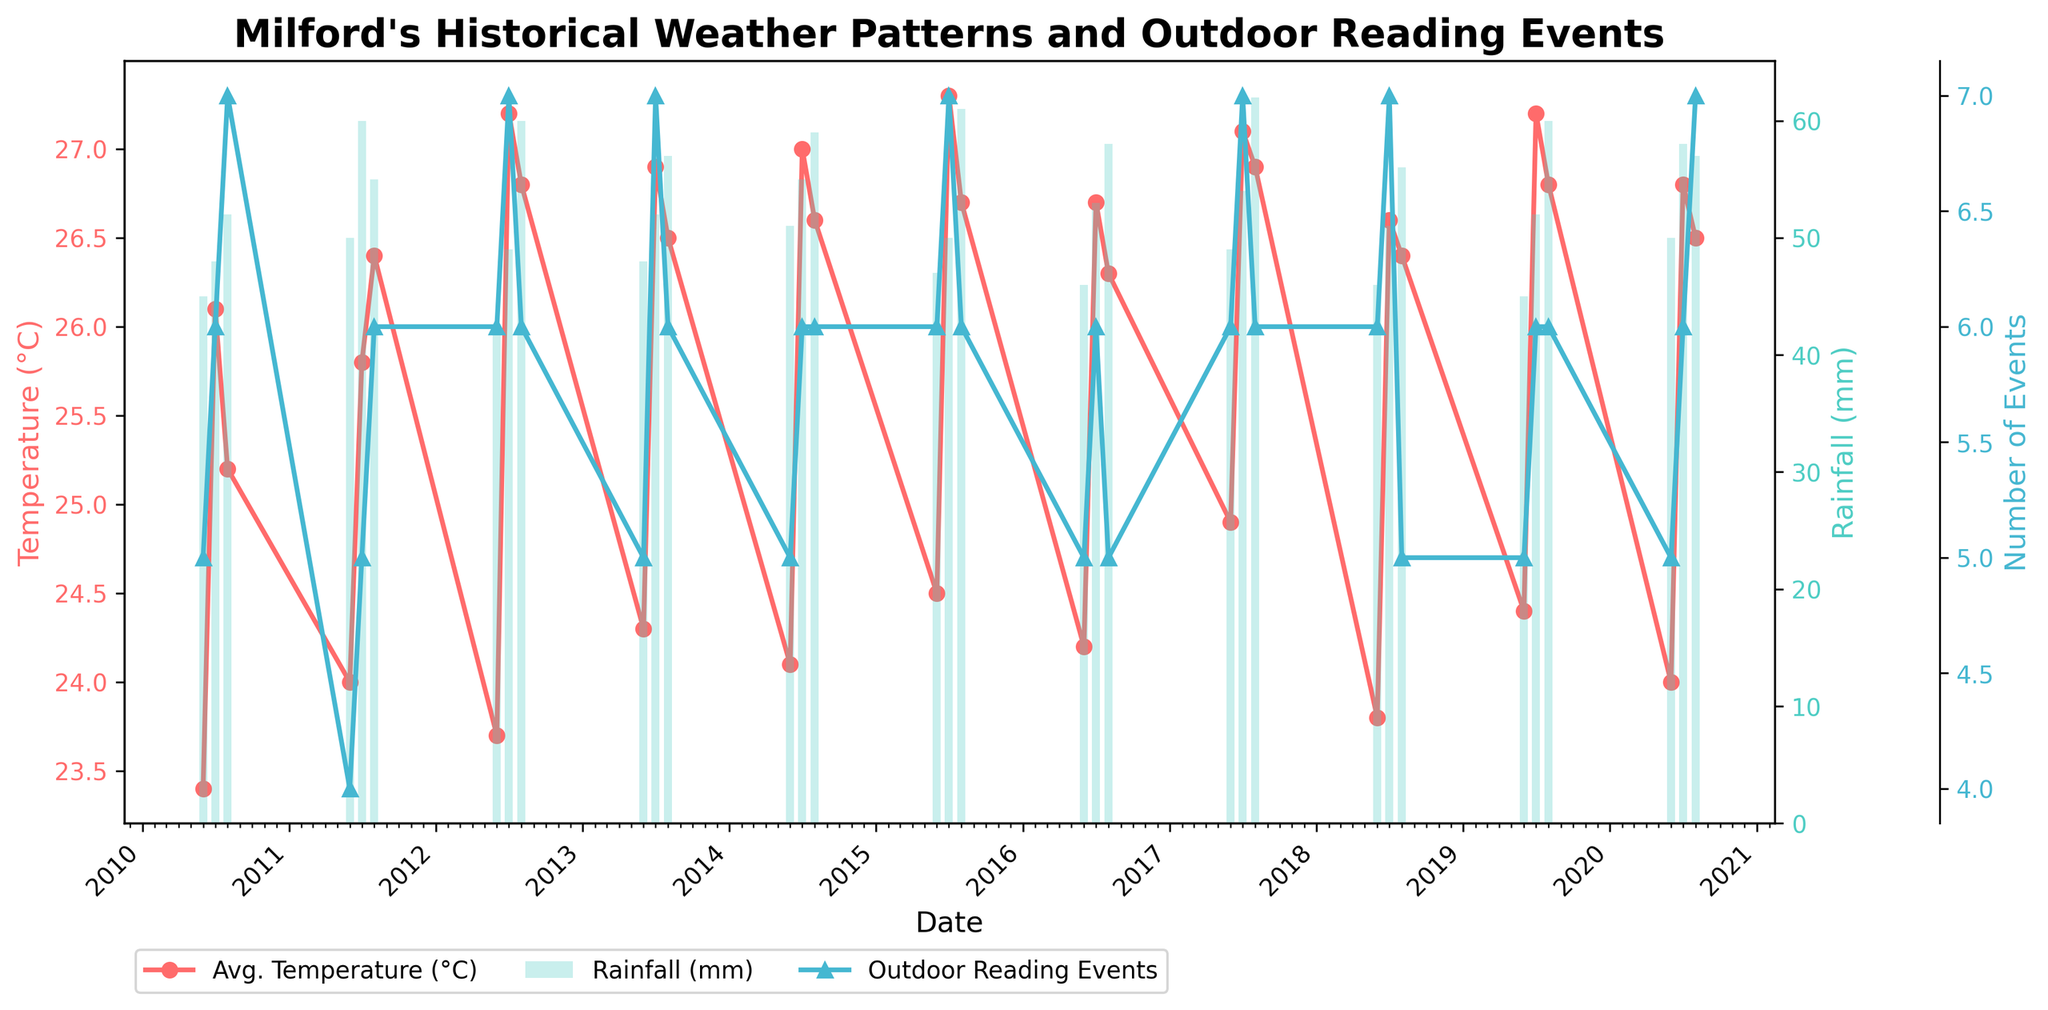What is the average temperature in July 2010? The average temperature in July 2010 can be directly read from the plot. It is represented by a red line where the date label shows July 2010.
Answer: 26.1°C How many outdoor reading events were held in June 2017? The number of outdoor reading events in June 2017 can be found by looking at the blue line with triangular markers on the plot for the date June 2017.
Answer: 6 What is the difference in rainfall between August 2015 and August 2020? Locate the rainfall (bar chart) for August 2015 and August 2020. Subtract the value in August 2015 from the value in August 2020. August 2015 has 61 mm of rainfall and August 2020 has 57 mm of rainfall, so 57 - 61 = -4 mm.
Answer: -4 mm Which year had the highest average temperature in July? To find the year with the highest average temperature in July, look at the peak points on the red line for each July starting from 2010 through 2020. The highest point corresponds to July 2015.
Answer: 2015 What is the median number of outdoor reading events in August across all years? To find the median, list the number of outdoor reading events for each August from 2010 to 2020: [7, 6, 6, 6, 6, 6, 6, 5, 6, 6, 7]. Sort the list: [5, 6, 6, 6, 6, 6, 6, 6, 6, 7, 7]. The median value (middlemost number in the sorted list) is 6.
Answer: 6 Which month experienced the least rainfall in 2018? Examine the bar chart segments for the year 2018. June, July, and August are visible. Compare the heights of the bars for June, July, and August. June has the shortest bar, indicating the least rainfall in 2018.
Answer: June By how much did the average temperature increase from June 2012 to July 2012? Find the red line points for June 2012 and July 2012. June 2012 had 23.7°C and July 2012 had 27.2°C. Subtract the June value from the July value: 27.2 - 23.7 = 3.5°C.
Answer: 3.5°C What trend can be seen in the number of outdoor reading events in July from 2010 to 2020? Look at the blue line with triangular markers across the years 2010 to 2020 for July. There is a general increase in the number of outdoor reading events over the years, stabilizing at around 6 to 7 events per year from 2012 onwards.
Answer: Increasing trend Did any August have no outdoor reading events? Check the blue line with triangular markers for each August from 2010 to 2020 and verify if any data point indicates zero events.
Answer: No 